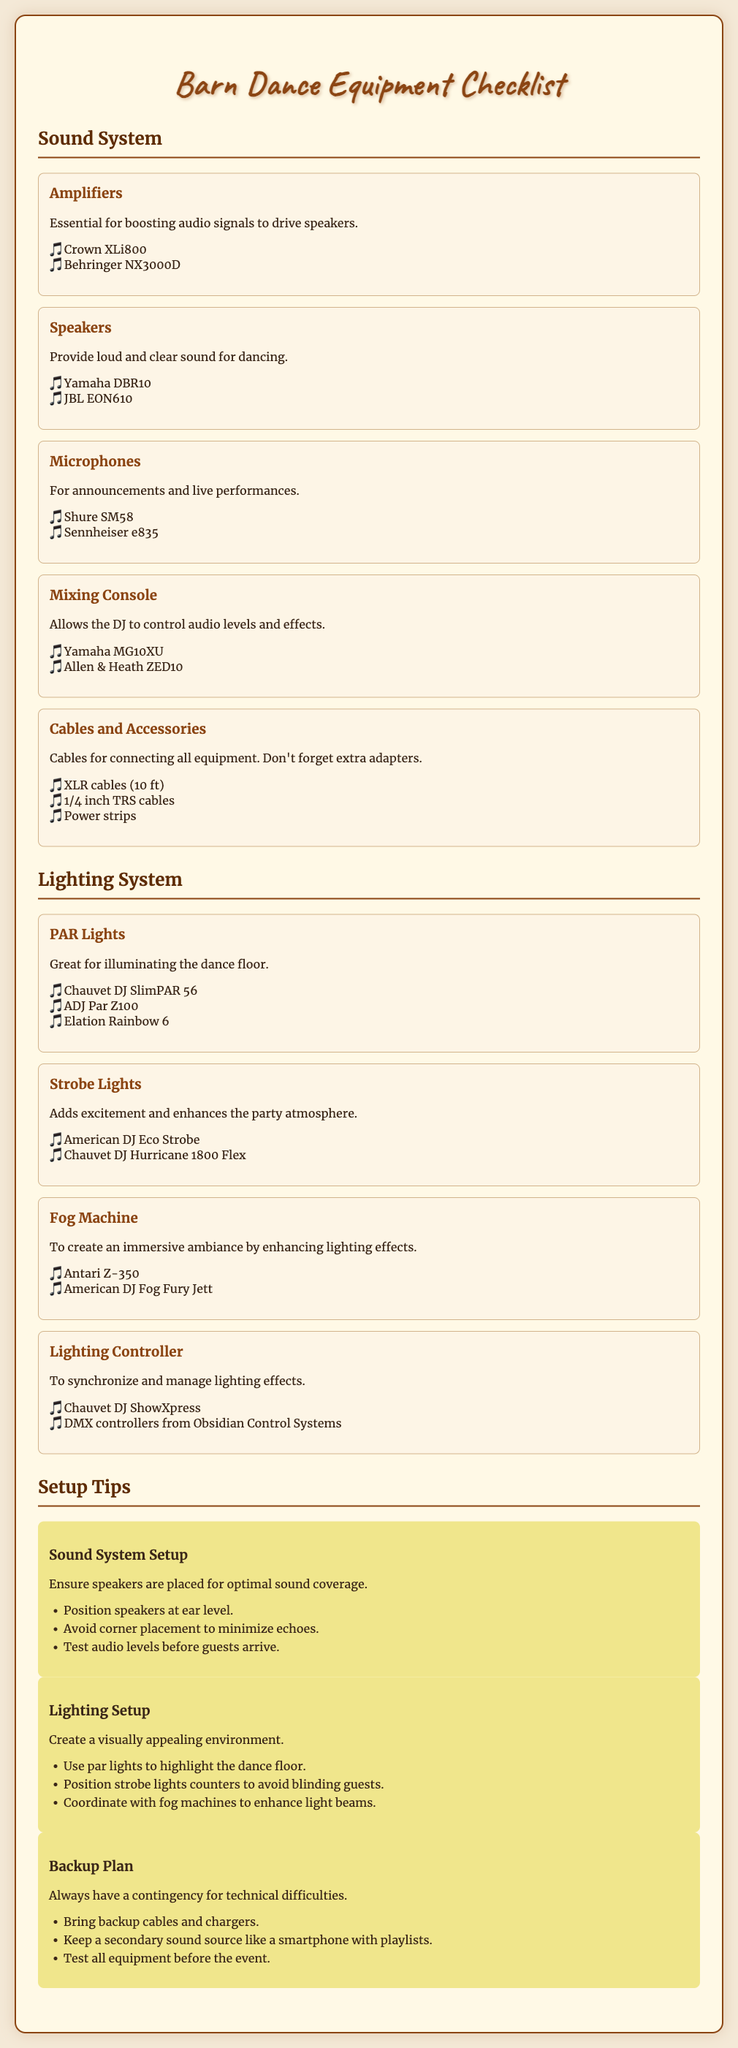what are the recommendations for amplifiers? The recommendations for amplifiers are listed in the sound system section of the document.
Answer: Crown XLi800, Behringer NX3000D which microphone is recommended? The recommended microphones can be found in the sound system section.
Answer: Shure SM58, Sennheiser e835 how many tips are provided for sound system setup? The setup tips for the sound system are detailed in their respective section, which lists specific points.
Answer: 3 tips what is the purpose of the fog machine? The fog machine's purpose is explained in the lighting system section, detailing its effect on ambiance.
Answer: To create an immersive ambiance by enhancing lighting effects which lighting controller is mentioned? The document specifies certain lighting controllers in the lighting system section.
Answer: Chauvet DJ ShowXpress, DMX controllers from Obsidian Control Systems how should speakers be positioned for optimal sound coverage? The document provides specific guidance about speaker placement in the setup tips.
Answer: Position speakers at ear level what is a crucial element of the backup plan? The backup plan section includes various elements to ensure preparedness for technical issues.
Answer: Bring backup cables and chargers what type of lights are recommended for illuminating the dance floor? The recommendation for dance floor illumination is found in the lighting system section.
Answer: PAR Lights 